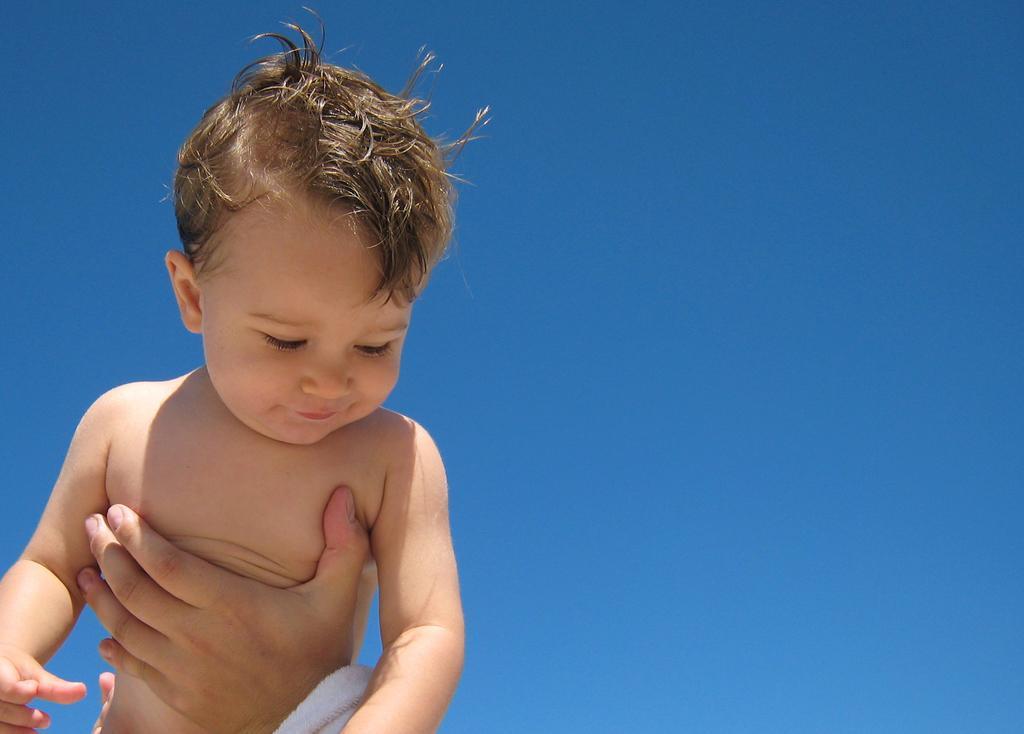Could you give a brief overview of what you see in this image? In this picture we can see a person´s hand here, we can see a kid here, in the background there is the sky. 